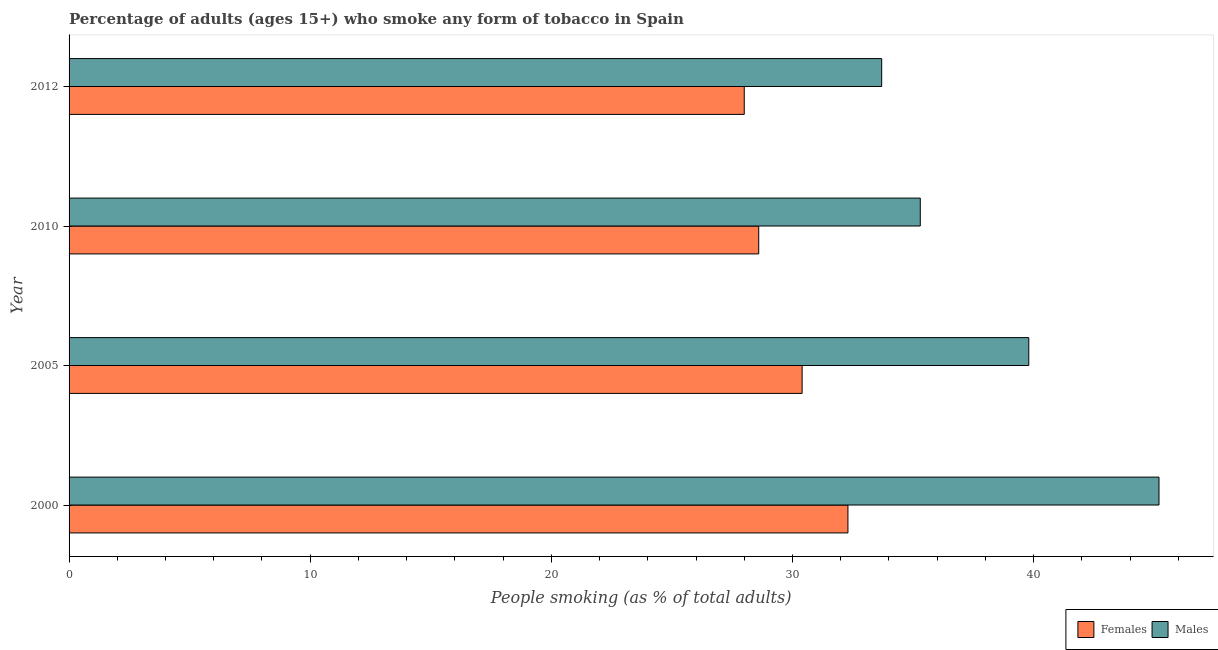How many different coloured bars are there?
Provide a short and direct response. 2. Are the number of bars on each tick of the Y-axis equal?
Make the answer very short. Yes. What is the label of the 2nd group of bars from the top?
Your answer should be compact. 2010. In how many cases, is the number of bars for a given year not equal to the number of legend labels?
Your answer should be compact. 0. What is the percentage of females who smoke in 2000?
Provide a succinct answer. 32.3. Across all years, what is the maximum percentage of males who smoke?
Make the answer very short. 45.2. Across all years, what is the minimum percentage of males who smoke?
Give a very brief answer. 33.7. In which year was the percentage of males who smoke maximum?
Your answer should be very brief. 2000. What is the total percentage of males who smoke in the graph?
Your response must be concise. 154. What is the difference between the percentage of females who smoke in 2010 and the percentage of males who smoke in 2012?
Provide a short and direct response. -5.1. What is the average percentage of females who smoke per year?
Your response must be concise. 29.82. In how many years, is the percentage of females who smoke greater than 4 %?
Provide a short and direct response. 4. What is the ratio of the percentage of females who smoke in 2000 to that in 2010?
Your answer should be very brief. 1.13. Is the percentage of females who smoke in 2000 less than that in 2005?
Ensure brevity in your answer.  No. What is the difference between the highest and the lowest percentage of males who smoke?
Give a very brief answer. 11.5. In how many years, is the percentage of females who smoke greater than the average percentage of females who smoke taken over all years?
Your answer should be compact. 2. What does the 1st bar from the top in 2010 represents?
Ensure brevity in your answer.  Males. What does the 1st bar from the bottom in 2010 represents?
Give a very brief answer. Females. Are all the bars in the graph horizontal?
Give a very brief answer. Yes. How many years are there in the graph?
Provide a short and direct response. 4. What is the difference between two consecutive major ticks on the X-axis?
Make the answer very short. 10. Are the values on the major ticks of X-axis written in scientific E-notation?
Ensure brevity in your answer.  No. Does the graph contain any zero values?
Keep it short and to the point. No. Does the graph contain grids?
Make the answer very short. No. How many legend labels are there?
Give a very brief answer. 2. How are the legend labels stacked?
Provide a succinct answer. Horizontal. What is the title of the graph?
Your answer should be compact. Percentage of adults (ages 15+) who smoke any form of tobacco in Spain. Does "Under-5(male)" appear as one of the legend labels in the graph?
Offer a very short reply. No. What is the label or title of the X-axis?
Keep it short and to the point. People smoking (as % of total adults). What is the label or title of the Y-axis?
Offer a very short reply. Year. What is the People smoking (as % of total adults) in Females in 2000?
Offer a very short reply. 32.3. What is the People smoking (as % of total adults) of Males in 2000?
Provide a short and direct response. 45.2. What is the People smoking (as % of total adults) in Females in 2005?
Make the answer very short. 30.4. What is the People smoking (as % of total adults) in Males in 2005?
Make the answer very short. 39.8. What is the People smoking (as % of total adults) in Females in 2010?
Your answer should be compact. 28.6. What is the People smoking (as % of total adults) in Males in 2010?
Offer a terse response. 35.3. What is the People smoking (as % of total adults) in Males in 2012?
Ensure brevity in your answer.  33.7. Across all years, what is the maximum People smoking (as % of total adults) of Females?
Offer a terse response. 32.3. Across all years, what is the maximum People smoking (as % of total adults) in Males?
Your answer should be compact. 45.2. Across all years, what is the minimum People smoking (as % of total adults) in Males?
Provide a short and direct response. 33.7. What is the total People smoking (as % of total adults) of Females in the graph?
Your answer should be very brief. 119.3. What is the total People smoking (as % of total adults) in Males in the graph?
Keep it short and to the point. 154. What is the difference between the People smoking (as % of total adults) of Females in 2000 and that in 2005?
Offer a terse response. 1.9. What is the difference between the People smoking (as % of total adults) of Males in 2000 and that in 2005?
Ensure brevity in your answer.  5.4. What is the difference between the People smoking (as % of total adults) in Females in 2000 and that in 2010?
Keep it short and to the point. 3.7. What is the difference between the People smoking (as % of total adults) of Males in 2000 and that in 2010?
Your answer should be compact. 9.9. What is the difference between the People smoking (as % of total adults) of Females in 2000 and that in 2012?
Give a very brief answer. 4.3. What is the difference between the People smoking (as % of total adults) of Males in 2000 and that in 2012?
Provide a succinct answer. 11.5. What is the difference between the People smoking (as % of total adults) of Females in 2005 and that in 2010?
Offer a terse response. 1.8. What is the difference between the People smoking (as % of total adults) of Males in 2005 and that in 2012?
Make the answer very short. 6.1. What is the difference between the People smoking (as % of total adults) of Females in 2010 and that in 2012?
Your answer should be very brief. 0.6. What is the difference between the People smoking (as % of total adults) in Males in 2010 and that in 2012?
Your answer should be very brief. 1.6. What is the difference between the People smoking (as % of total adults) of Females in 2000 and the People smoking (as % of total adults) of Males in 2005?
Make the answer very short. -7.5. What is the difference between the People smoking (as % of total adults) in Females in 2000 and the People smoking (as % of total adults) in Males in 2012?
Provide a succinct answer. -1.4. What is the difference between the People smoking (as % of total adults) in Females in 2005 and the People smoking (as % of total adults) in Males in 2010?
Keep it short and to the point. -4.9. What is the difference between the People smoking (as % of total adults) of Females in 2010 and the People smoking (as % of total adults) of Males in 2012?
Your answer should be very brief. -5.1. What is the average People smoking (as % of total adults) in Females per year?
Your answer should be very brief. 29.82. What is the average People smoking (as % of total adults) of Males per year?
Offer a terse response. 38.5. In the year 2012, what is the difference between the People smoking (as % of total adults) in Females and People smoking (as % of total adults) in Males?
Your response must be concise. -5.7. What is the ratio of the People smoking (as % of total adults) in Males in 2000 to that in 2005?
Provide a succinct answer. 1.14. What is the ratio of the People smoking (as % of total adults) in Females in 2000 to that in 2010?
Ensure brevity in your answer.  1.13. What is the ratio of the People smoking (as % of total adults) in Males in 2000 to that in 2010?
Offer a terse response. 1.28. What is the ratio of the People smoking (as % of total adults) of Females in 2000 to that in 2012?
Offer a terse response. 1.15. What is the ratio of the People smoking (as % of total adults) of Males in 2000 to that in 2012?
Offer a very short reply. 1.34. What is the ratio of the People smoking (as % of total adults) of Females in 2005 to that in 2010?
Your answer should be very brief. 1.06. What is the ratio of the People smoking (as % of total adults) in Males in 2005 to that in 2010?
Give a very brief answer. 1.13. What is the ratio of the People smoking (as % of total adults) of Females in 2005 to that in 2012?
Your answer should be compact. 1.09. What is the ratio of the People smoking (as % of total adults) in Males in 2005 to that in 2012?
Keep it short and to the point. 1.18. What is the ratio of the People smoking (as % of total adults) in Females in 2010 to that in 2012?
Give a very brief answer. 1.02. What is the ratio of the People smoking (as % of total adults) of Males in 2010 to that in 2012?
Your answer should be very brief. 1.05. What is the difference between the highest and the second highest People smoking (as % of total adults) in Females?
Keep it short and to the point. 1.9. What is the difference between the highest and the lowest People smoking (as % of total adults) of Males?
Your answer should be very brief. 11.5. 